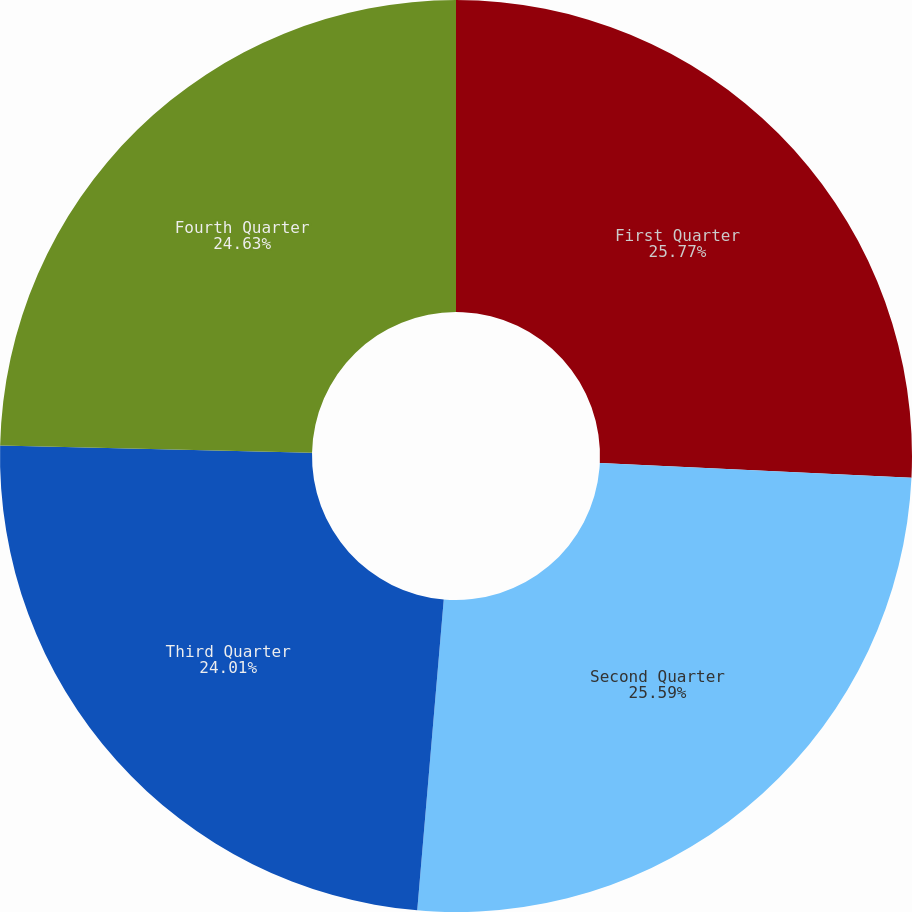<chart> <loc_0><loc_0><loc_500><loc_500><pie_chart><fcel>First Quarter<fcel>Second Quarter<fcel>Third Quarter<fcel>Fourth Quarter<nl><fcel>25.76%<fcel>25.59%<fcel>24.01%<fcel>24.63%<nl></chart> 